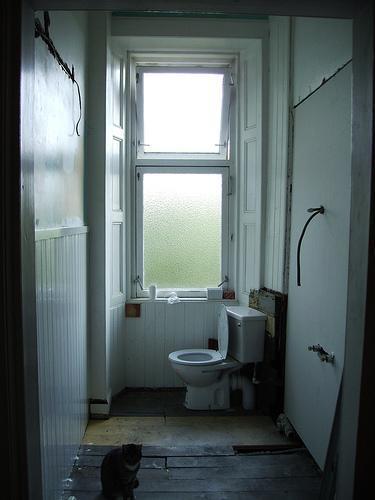How many zebras are pictured?
Give a very brief answer. 0. 